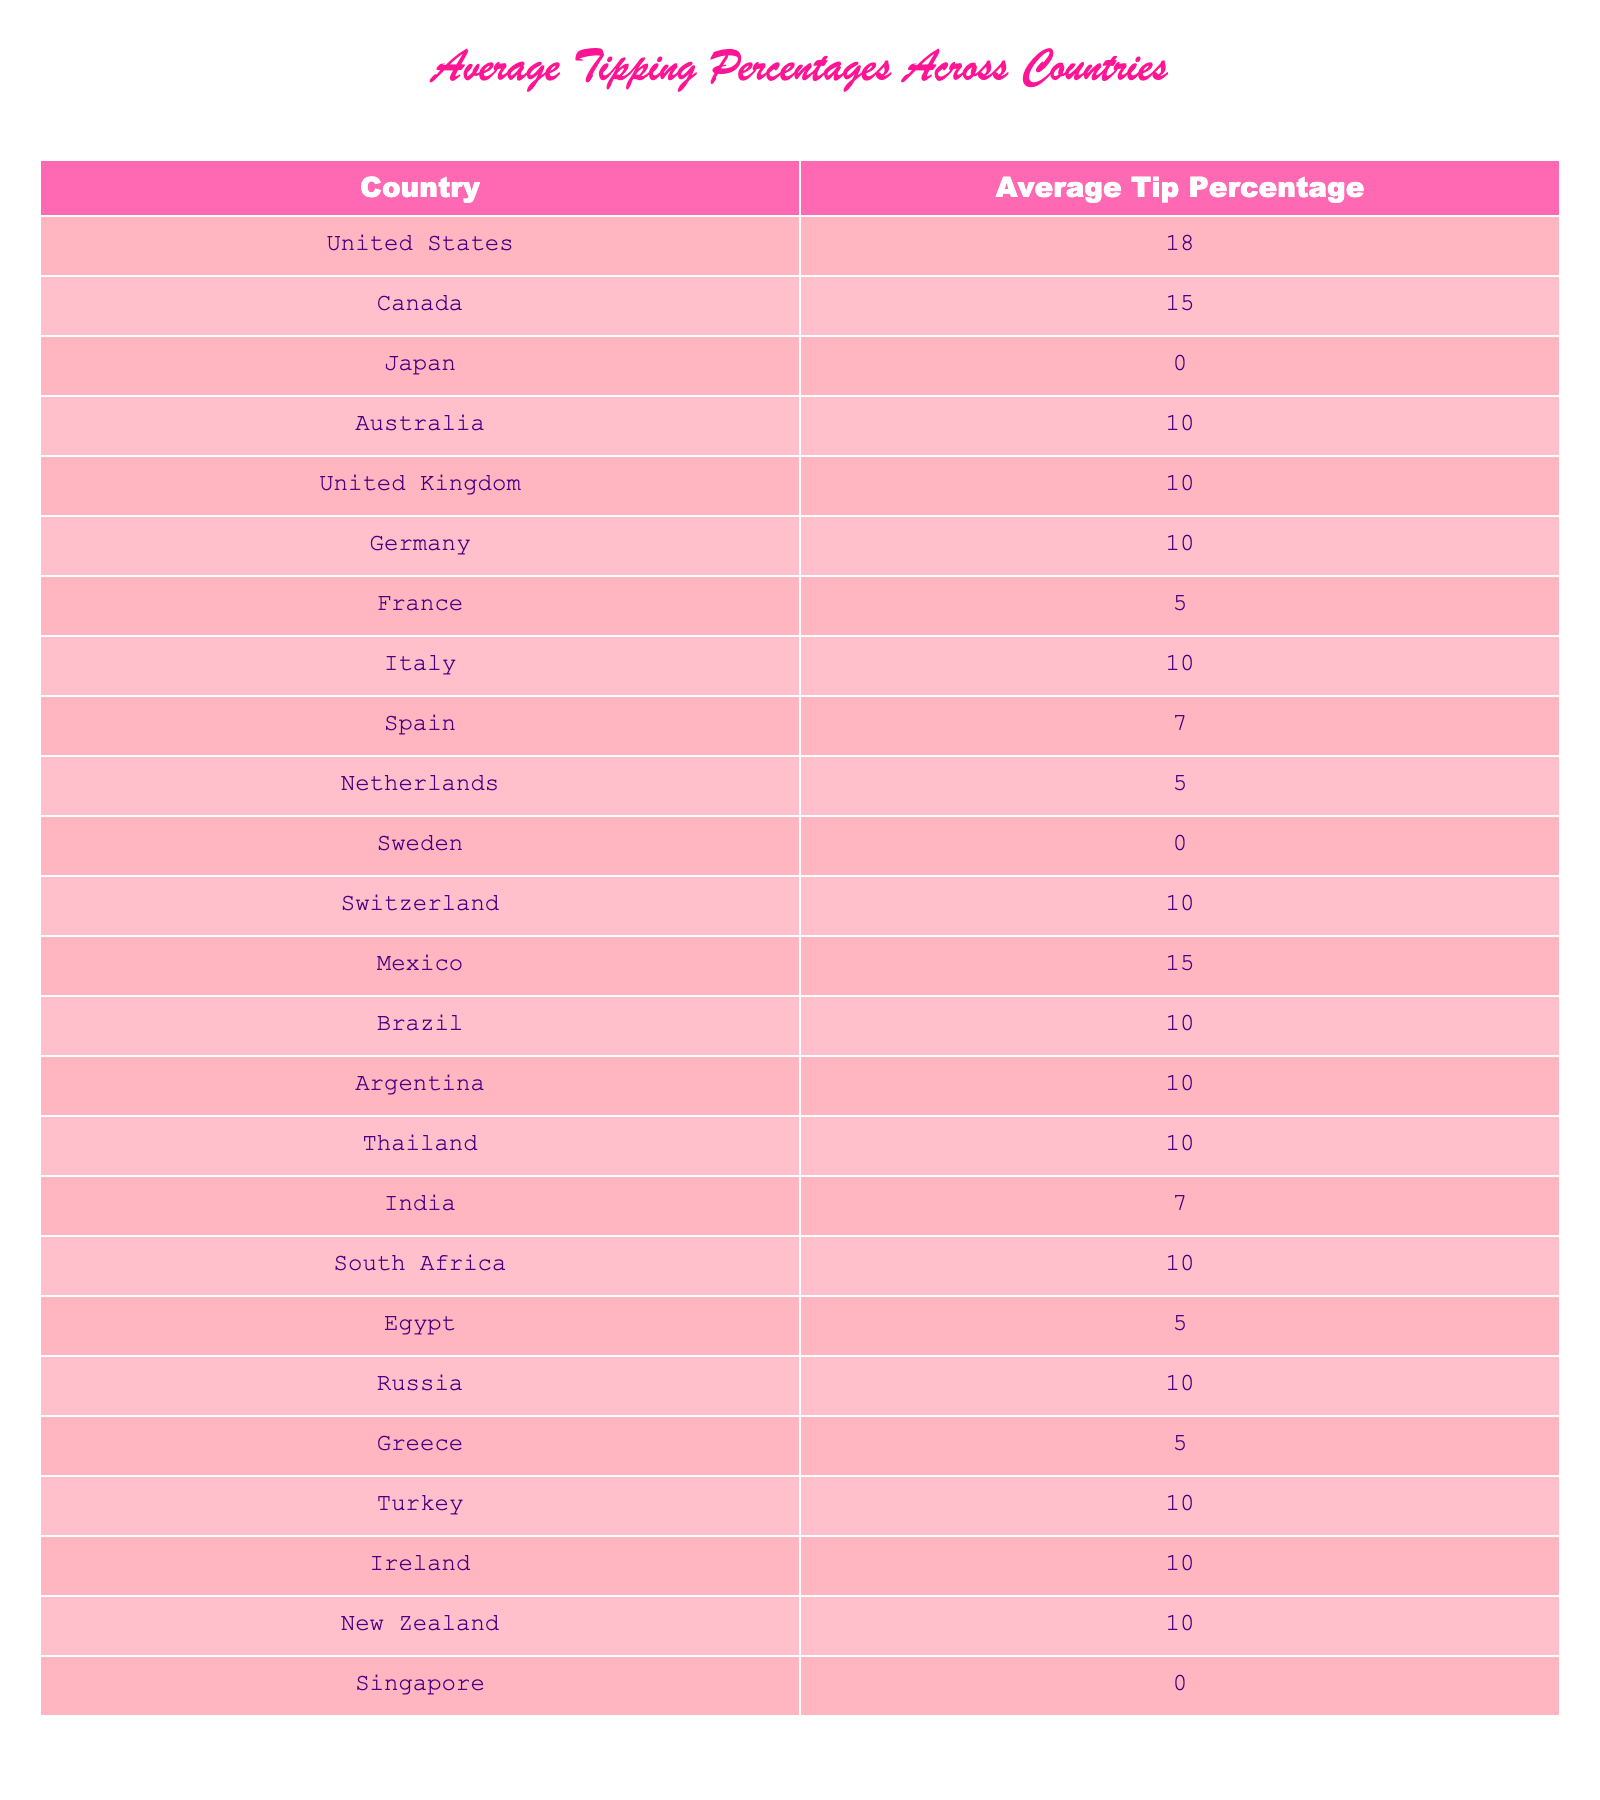What's the average tipping percentage in Japan? The table shows that the average tip percentage in Japan is listed as 0%.
Answer: 0% Which country has the highest average tipping percentage? The table indicates that the United States has the highest average tipping percentage at 18%.
Answer: 18% How many countries have an average tipping percentage of 10%? By counting the entries in the table, I find that there are 8 countries listed with an average tipping percentage of 10%.
Answer: 8 What is the average tipping percentage of the countries in Europe? The European countries listed and their tip percentages are United Kingdom (10%), Germany (10%), France (5%), Italy (10%), Spain (7%), Netherlands (5%), Sweden (0%), Switzerland (10%), Greece (5%), and Ireland (10%). Summing these percentages gives a total of 72%, and dividing by 10 countries results in an average of 7.2%.
Answer: 7.2% Is it true that all countries listed in the table have a positive average tipping percentage? No, the table shows that both Japan and Sweden have an average tipping percentage of 0%, which means they do not have a positive value.
Answer: False What is the difference between the average tipping percentages of the United States and Canada? The average tipping percentage for the United States is 18% and for Canada is 15%. Calculating the difference gives 18% - 15% = 3%.
Answer: 3% Which countries have the same average tipping percentage as Mexico? The table shows that Mexico has an average tip percentage of 15%. By reviewing the entries, I see that Canada also has an average of 15%.
Answer: Canada What percentage of the countries listed have an average tipping percentage of less than 10%? There are 6 countries with tip percentages that are less than 10% (Japan, Sweden, France, Netherlands, Greece, and Egypt) out of a total of 25 countries. Calculating the percentage gives (6/25) * 100 = 24%.
Answer: 24% How many countries in the table have an average tip percentage equal to or greater than 10%? Counting the countries with percentages of 10% or greater (United States, Canada, Australia, United Kingdom, Germany, Italy, Switzerland, Brazil, Argentina, Thailand, South Africa, Turkey, Ireland, New Zealand), I find there are 14 countries.
Answer: 14 What is the total average tipping percentage of the Latin American countries listed? The table includes Mexico (15%), Brazil (10%), and Argentina (10%). Summing these gives a total of 15 + 10 + 10 = 35%. Averaging this over 3 countries results in 35/3 = approximately 11.67%.
Answer: 11.67% 